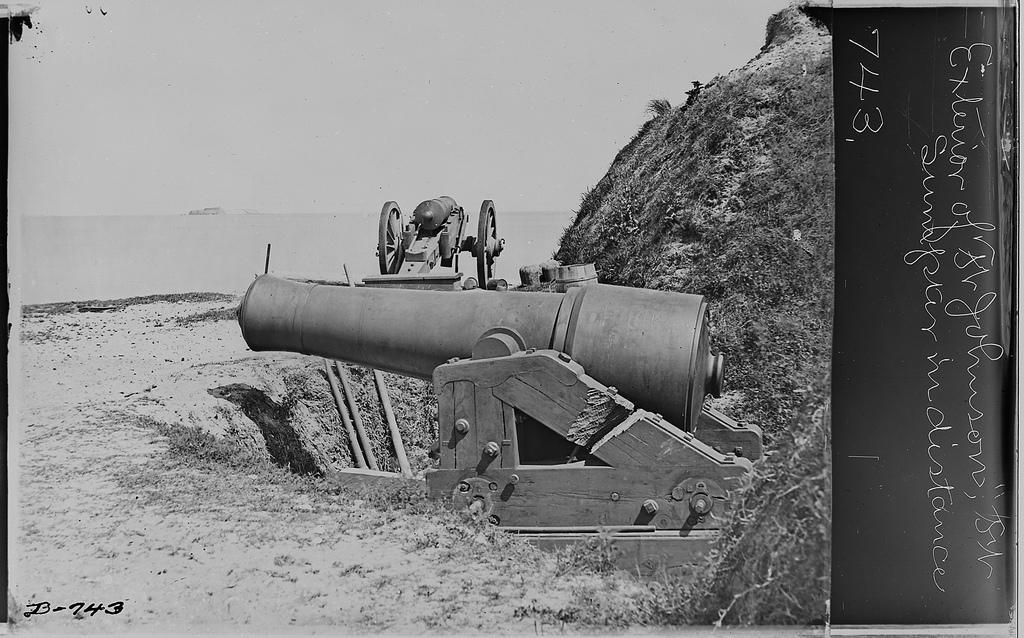Describe this image in one or two sentences. In this picture we can see one mechanic is placed beside the road and far we can see some water. 